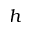<formula> <loc_0><loc_0><loc_500><loc_500>h</formula> 